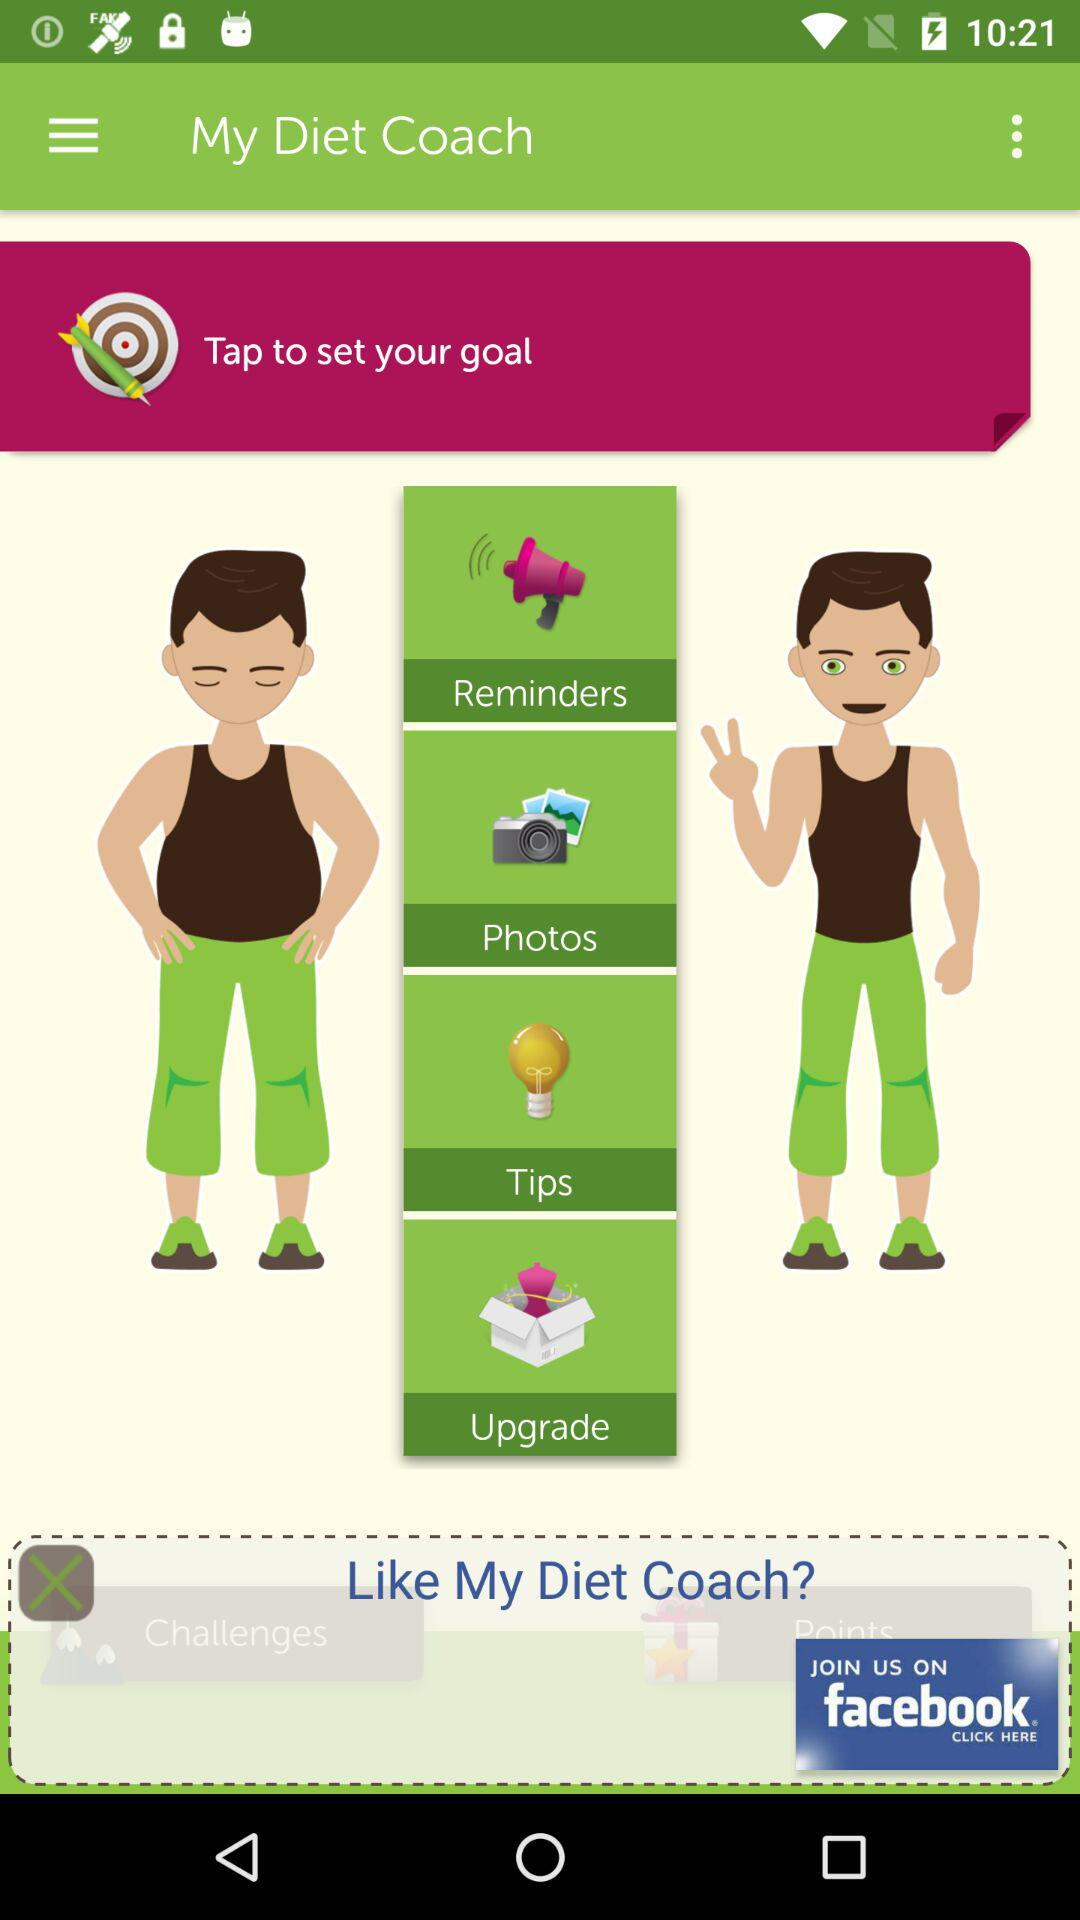What is the app name? The app name is "My Diet Coach". 